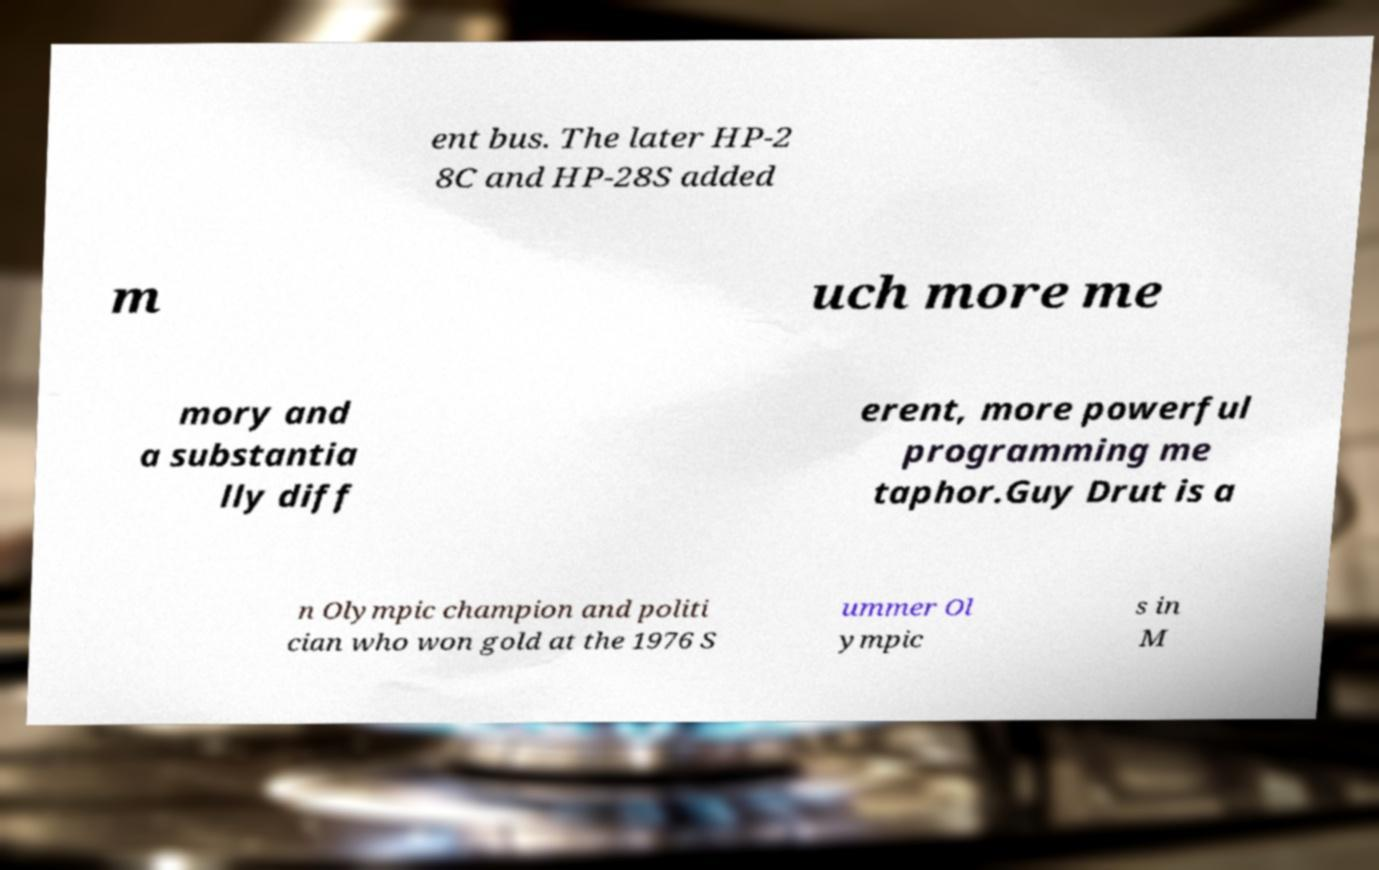Can you read and provide the text displayed in the image?This photo seems to have some interesting text. Can you extract and type it out for me? ent bus. The later HP-2 8C and HP-28S added m uch more me mory and a substantia lly diff erent, more powerful programming me taphor.Guy Drut is a n Olympic champion and politi cian who won gold at the 1976 S ummer Ol ympic s in M 